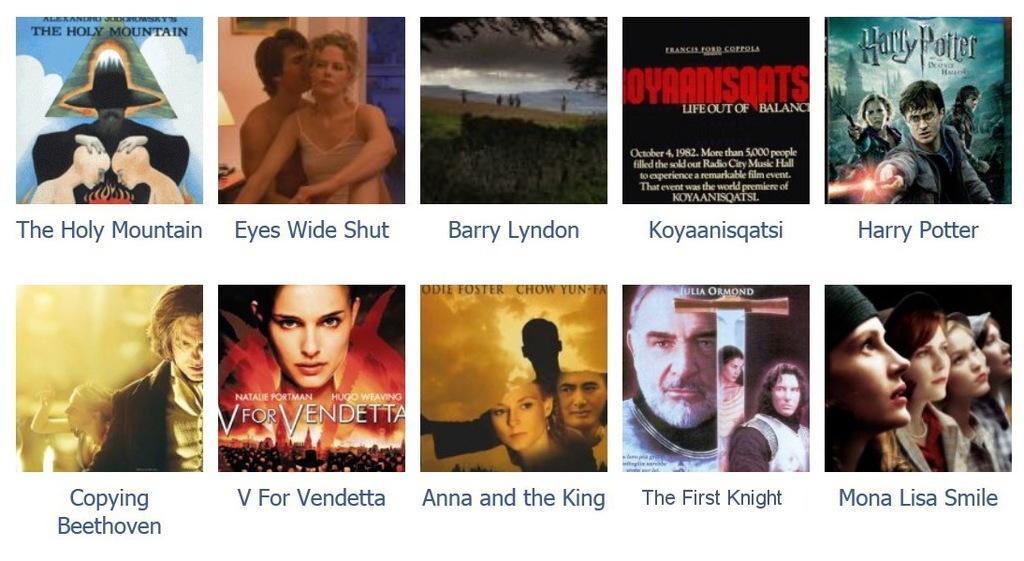Can you describe this image briefly? In this I can see ten images which looks like a front covers of books. In this I can see group of people, trees, mountains, text and the sky. 